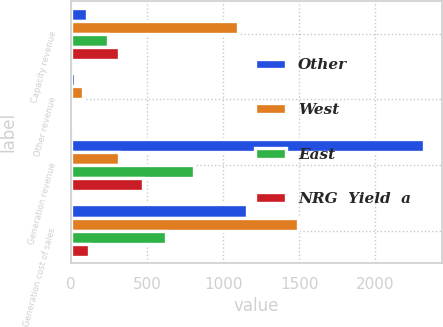Convert chart to OTSL. <chart><loc_0><loc_0><loc_500><loc_500><stacked_bar_chart><ecel><fcel>Capacity revenue<fcel>Other revenue<fcel>Generation revenue<fcel>Generation cost of sales<nl><fcel>Other<fcel>103<fcel>28<fcel>2321<fcel>1156<nl><fcel>West<fcel>1099<fcel>76<fcel>314<fcel>1492<nl><fcel>East<fcel>245<fcel>1<fcel>810<fcel>623<nl><fcel>NRG  Yield  a<fcel>314<fcel>4<fcel>473<fcel>119<nl></chart> 